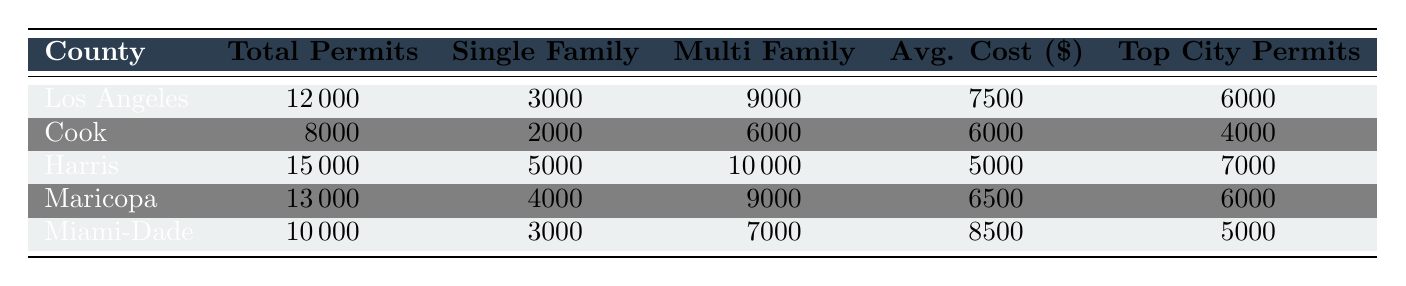What county issued the highest number of total permits in 2023? Referring to the table, Harris County has issued the highest total permits, which is 15,000.
Answer: Harris County How many multi-family units were permitted in Cook County? Cook County has issued 6,000 multi-family units, as seen in the table.
Answer: 6000 What is the average permit cost for single-family homes in Los Angeles County? The average permit cost for single-family homes in Los Angeles County is $7,500, as indicated in the table.
Answer: 7500 What is the total number of single-family homes and multi-family units combined in Maricopa County? Maricopa County has 4,000 single-family homes and 9,000 multi-family units. Adding these gives 4,000 + 9,000 = 13,000.
Answer: 13000 Which county has the lowest average permit cost? Comparing the average costs, Harris County is the lowest at $5,000.
Answer: Harris County What percentage of total permits issued in Miami-Dade County were for single-family homes? Miami-Dade County issued 10,000 total permits, with 3,000 being for single-family homes. The percentage is (3,000 / 10,000) * 100 = 30%.
Answer: 30% If you combined the total permits from Los Angeles County and Miami-Dade County, how many would that be? Los Angeles County has 12,000 permits and Miami-Dade has 10,000. Adding these gives 12,000 + 10,000 = 22,000.
Answer: 22000 Is the total number of permits issued in Maricopa County equal to the total in Los Angeles County? Maricopa County has 13,000 total permits while Los Angeles County has 12,000. Therefore, they are not equal.
Answer: No What city issued the most permits in Harris County? The city of Houston issued the most permits in Harris County with 7,000 permits, as shown in the table.
Answer: Houston Which county has more single-family homes permitted: Cook or Miami-Dade? Cook County has 2,000 single-family homes while Miami-Dade has 3,000. Therefore, Miami-Dade has more.
Answer: Miami-Dade What is the difference in total permits issued between Harris County and Cook County? Harris County issued 15,000 permits, and Cook County issued 8,000 permits. The difference is 15,000 - 8,000 = 7,000.
Answer: 7000 